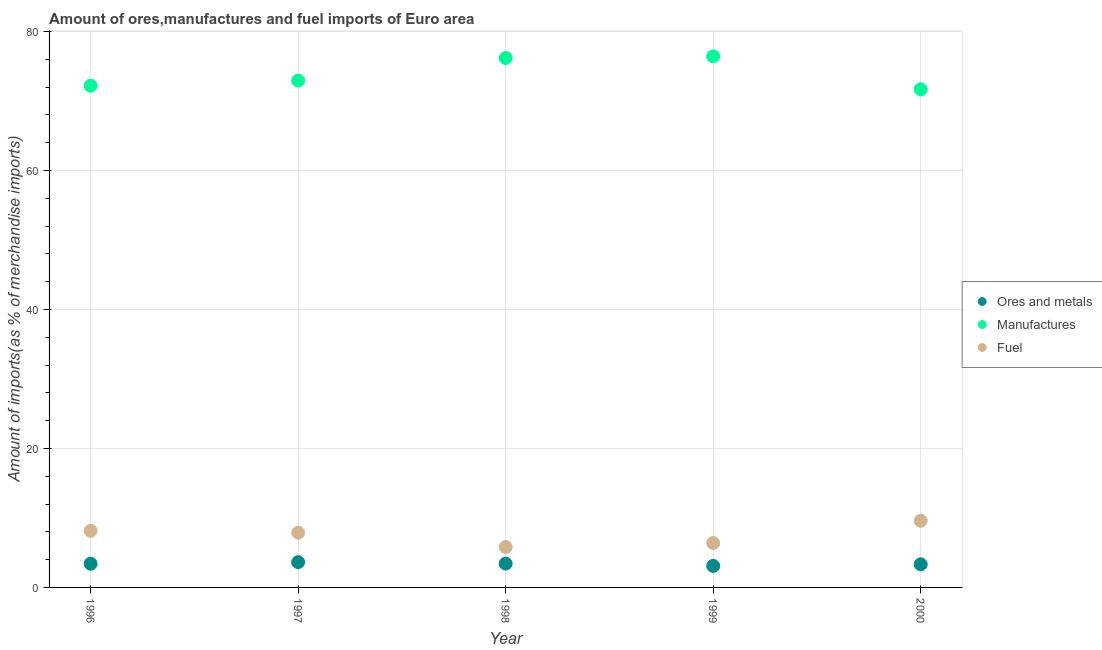How many different coloured dotlines are there?
Provide a short and direct response. 3. What is the percentage of manufactures imports in 1997?
Your response must be concise. 72.94. Across all years, what is the maximum percentage of fuel imports?
Offer a very short reply. 9.59. Across all years, what is the minimum percentage of fuel imports?
Offer a terse response. 5.81. In which year was the percentage of ores and metals imports minimum?
Provide a short and direct response. 1999. What is the total percentage of ores and metals imports in the graph?
Offer a terse response. 16.9. What is the difference between the percentage of ores and metals imports in 1996 and that in 1999?
Your answer should be compact. 0.31. What is the difference between the percentage of ores and metals imports in 1997 and the percentage of fuel imports in 2000?
Provide a succinct answer. -5.95. What is the average percentage of ores and metals imports per year?
Offer a very short reply. 3.38. In the year 1997, what is the difference between the percentage of fuel imports and percentage of ores and metals imports?
Offer a terse response. 4.24. In how many years, is the percentage of fuel imports greater than 40 %?
Provide a succinct answer. 0. What is the ratio of the percentage of ores and metals imports in 1996 to that in 1999?
Provide a succinct answer. 1.1. Is the percentage of ores and metals imports in 1997 less than that in 2000?
Offer a terse response. No. Is the difference between the percentage of ores and metals imports in 1996 and 2000 greater than the difference between the percentage of fuel imports in 1996 and 2000?
Ensure brevity in your answer.  Yes. What is the difference between the highest and the second highest percentage of ores and metals imports?
Provide a succinct answer. 0.21. What is the difference between the highest and the lowest percentage of manufactures imports?
Offer a terse response. 4.74. Is the sum of the percentage of manufactures imports in 1999 and 2000 greater than the maximum percentage of fuel imports across all years?
Your answer should be compact. Yes. Is it the case that in every year, the sum of the percentage of ores and metals imports and percentage of manufactures imports is greater than the percentage of fuel imports?
Ensure brevity in your answer.  Yes. Is the percentage of fuel imports strictly greater than the percentage of ores and metals imports over the years?
Provide a succinct answer. Yes. How many dotlines are there?
Offer a terse response. 3. How many years are there in the graph?
Your answer should be compact. 5. Does the graph contain any zero values?
Ensure brevity in your answer.  No. How many legend labels are there?
Ensure brevity in your answer.  3. How are the legend labels stacked?
Offer a very short reply. Vertical. What is the title of the graph?
Make the answer very short. Amount of ores,manufactures and fuel imports of Euro area. What is the label or title of the Y-axis?
Provide a short and direct response. Amount of imports(as % of merchandise imports). What is the Amount of imports(as % of merchandise imports) in Ores and metals in 1996?
Give a very brief answer. 3.41. What is the Amount of imports(as % of merchandise imports) of Manufactures in 1996?
Keep it short and to the point. 72.2. What is the Amount of imports(as % of merchandise imports) in Fuel in 1996?
Offer a terse response. 8.15. What is the Amount of imports(as % of merchandise imports) of Ores and metals in 1997?
Your answer should be compact. 3.64. What is the Amount of imports(as % of merchandise imports) of Manufactures in 1997?
Provide a short and direct response. 72.94. What is the Amount of imports(as % of merchandise imports) of Fuel in 1997?
Your answer should be compact. 7.88. What is the Amount of imports(as % of merchandise imports) of Ores and metals in 1998?
Your answer should be very brief. 3.43. What is the Amount of imports(as % of merchandise imports) in Manufactures in 1998?
Offer a very short reply. 76.19. What is the Amount of imports(as % of merchandise imports) of Fuel in 1998?
Provide a succinct answer. 5.81. What is the Amount of imports(as % of merchandise imports) of Ores and metals in 1999?
Keep it short and to the point. 3.1. What is the Amount of imports(as % of merchandise imports) in Manufactures in 1999?
Keep it short and to the point. 76.43. What is the Amount of imports(as % of merchandise imports) of Fuel in 1999?
Offer a very short reply. 6.39. What is the Amount of imports(as % of merchandise imports) in Ores and metals in 2000?
Make the answer very short. 3.33. What is the Amount of imports(as % of merchandise imports) of Manufactures in 2000?
Provide a succinct answer. 71.69. What is the Amount of imports(as % of merchandise imports) in Fuel in 2000?
Keep it short and to the point. 9.59. Across all years, what is the maximum Amount of imports(as % of merchandise imports) of Ores and metals?
Offer a terse response. 3.64. Across all years, what is the maximum Amount of imports(as % of merchandise imports) of Manufactures?
Your answer should be compact. 76.43. Across all years, what is the maximum Amount of imports(as % of merchandise imports) of Fuel?
Provide a succinct answer. 9.59. Across all years, what is the minimum Amount of imports(as % of merchandise imports) in Ores and metals?
Ensure brevity in your answer.  3.1. Across all years, what is the minimum Amount of imports(as % of merchandise imports) of Manufactures?
Make the answer very short. 71.69. Across all years, what is the minimum Amount of imports(as % of merchandise imports) in Fuel?
Offer a very short reply. 5.81. What is the total Amount of imports(as % of merchandise imports) of Ores and metals in the graph?
Provide a succinct answer. 16.9. What is the total Amount of imports(as % of merchandise imports) of Manufactures in the graph?
Give a very brief answer. 369.44. What is the total Amount of imports(as % of merchandise imports) of Fuel in the graph?
Provide a short and direct response. 37.82. What is the difference between the Amount of imports(as % of merchandise imports) of Ores and metals in 1996 and that in 1997?
Provide a succinct answer. -0.23. What is the difference between the Amount of imports(as % of merchandise imports) of Manufactures in 1996 and that in 1997?
Offer a terse response. -0.73. What is the difference between the Amount of imports(as % of merchandise imports) in Fuel in 1996 and that in 1997?
Your answer should be very brief. 0.27. What is the difference between the Amount of imports(as % of merchandise imports) in Ores and metals in 1996 and that in 1998?
Offer a very short reply. -0.02. What is the difference between the Amount of imports(as % of merchandise imports) in Manufactures in 1996 and that in 1998?
Make the answer very short. -3.98. What is the difference between the Amount of imports(as % of merchandise imports) of Fuel in 1996 and that in 1998?
Make the answer very short. 2.34. What is the difference between the Amount of imports(as % of merchandise imports) in Ores and metals in 1996 and that in 1999?
Provide a short and direct response. 0.31. What is the difference between the Amount of imports(as % of merchandise imports) in Manufactures in 1996 and that in 1999?
Provide a short and direct response. -4.23. What is the difference between the Amount of imports(as % of merchandise imports) of Fuel in 1996 and that in 1999?
Offer a terse response. 1.76. What is the difference between the Amount of imports(as % of merchandise imports) of Ores and metals in 1996 and that in 2000?
Your response must be concise. 0.08. What is the difference between the Amount of imports(as % of merchandise imports) in Manufactures in 1996 and that in 2000?
Make the answer very short. 0.51. What is the difference between the Amount of imports(as % of merchandise imports) in Fuel in 1996 and that in 2000?
Provide a short and direct response. -1.44. What is the difference between the Amount of imports(as % of merchandise imports) in Ores and metals in 1997 and that in 1998?
Ensure brevity in your answer.  0.21. What is the difference between the Amount of imports(as % of merchandise imports) of Manufactures in 1997 and that in 1998?
Ensure brevity in your answer.  -3.25. What is the difference between the Amount of imports(as % of merchandise imports) in Fuel in 1997 and that in 1998?
Provide a succinct answer. 2.06. What is the difference between the Amount of imports(as % of merchandise imports) in Ores and metals in 1997 and that in 1999?
Provide a succinct answer. 0.54. What is the difference between the Amount of imports(as % of merchandise imports) of Manufactures in 1997 and that in 1999?
Your answer should be compact. -3.49. What is the difference between the Amount of imports(as % of merchandise imports) in Fuel in 1997 and that in 1999?
Your response must be concise. 1.49. What is the difference between the Amount of imports(as % of merchandise imports) of Ores and metals in 1997 and that in 2000?
Make the answer very short. 0.31. What is the difference between the Amount of imports(as % of merchandise imports) of Manufactures in 1997 and that in 2000?
Keep it short and to the point. 1.25. What is the difference between the Amount of imports(as % of merchandise imports) of Fuel in 1997 and that in 2000?
Your answer should be compact. -1.71. What is the difference between the Amount of imports(as % of merchandise imports) of Ores and metals in 1998 and that in 1999?
Offer a very short reply. 0.33. What is the difference between the Amount of imports(as % of merchandise imports) of Manufactures in 1998 and that in 1999?
Your answer should be very brief. -0.25. What is the difference between the Amount of imports(as % of merchandise imports) of Fuel in 1998 and that in 1999?
Make the answer very short. -0.58. What is the difference between the Amount of imports(as % of merchandise imports) of Ores and metals in 1998 and that in 2000?
Keep it short and to the point. 0.1. What is the difference between the Amount of imports(as % of merchandise imports) in Manufactures in 1998 and that in 2000?
Your response must be concise. 4.5. What is the difference between the Amount of imports(as % of merchandise imports) of Fuel in 1998 and that in 2000?
Offer a very short reply. -3.78. What is the difference between the Amount of imports(as % of merchandise imports) in Ores and metals in 1999 and that in 2000?
Your answer should be compact. -0.23. What is the difference between the Amount of imports(as % of merchandise imports) of Manufactures in 1999 and that in 2000?
Keep it short and to the point. 4.74. What is the difference between the Amount of imports(as % of merchandise imports) in Fuel in 1999 and that in 2000?
Your answer should be compact. -3.2. What is the difference between the Amount of imports(as % of merchandise imports) in Ores and metals in 1996 and the Amount of imports(as % of merchandise imports) in Manufactures in 1997?
Make the answer very short. -69.53. What is the difference between the Amount of imports(as % of merchandise imports) in Ores and metals in 1996 and the Amount of imports(as % of merchandise imports) in Fuel in 1997?
Make the answer very short. -4.47. What is the difference between the Amount of imports(as % of merchandise imports) in Manufactures in 1996 and the Amount of imports(as % of merchandise imports) in Fuel in 1997?
Offer a very short reply. 64.32. What is the difference between the Amount of imports(as % of merchandise imports) in Ores and metals in 1996 and the Amount of imports(as % of merchandise imports) in Manufactures in 1998?
Keep it short and to the point. -72.78. What is the difference between the Amount of imports(as % of merchandise imports) of Ores and metals in 1996 and the Amount of imports(as % of merchandise imports) of Fuel in 1998?
Your answer should be compact. -2.41. What is the difference between the Amount of imports(as % of merchandise imports) of Manufactures in 1996 and the Amount of imports(as % of merchandise imports) of Fuel in 1998?
Provide a short and direct response. 66.39. What is the difference between the Amount of imports(as % of merchandise imports) in Ores and metals in 1996 and the Amount of imports(as % of merchandise imports) in Manufactures in 1999?
Your answer should be very brief. -73.02. What is the difference between the Amount of imports(as % of merchandise imports) in Ores and metals in 1996 and the Amount of imports(as % of merchandise imports) in Fuel in 1999?
Ensure brevity in your answer.  -2.98. What is the difference between the Amount of imports(as % of merchandise imports) of Manufactures in 1996 and the Amount of imports(as % of merchandise imports) of Fuel in 1999?
Ensure brevity in your answer.  65.81. What is the difference between the Amount of imports(as % of merchandise imports) in Ores and metals in 1996 and the Amount of imports(as % of merchandise imports) in Manufactures in 2000?
Make the answer very short. -68.28. What is the difference between the Amount of imports(as % of merchandise imports) in Ores and metals in 1996 and the Amount of imports(as % of merchandise imports) in Fuel in 2000?
Your response must be concise. -6.18. What is the difference between the Amount of imports(as % of merchandise imports) in Manufactures in 1996 and the Amount of imports(as % of merchandise imports) in Fuel in 2000?
Your answer should be compact. 62.61. What is the difference between the Amount of imports(as % of merchandise imports) in Ores and metals in 1997 and the Amount of imports(as % of merchandise imports) in Manufactures in 1998?
Offer a terse response. -72.55. What is the difference between the Amount of imports(as % of merchandise imports) in Ores and metals in 1997 and the Amount of imports(as % of merchandise imports) in Fuel in 1998?
Keep it short and to the point. -2.18. What is the difference between the Amount of imports(as % of merchandise imports) of Manufactures in 1997 and the Amount of imports(as % of merchandise imports) of Fuel in 1998?
Offer a terse response. 67.12. What is the difference between the Amount of imports(as % of merchandise imports) in Ores and metals in 1997 and the Amount of imports(as % of merchandise imports) in Manufactures in 1999?
Your answer should be very brief. -72.79. What is the difference between the Amount of imports(as % of merchandise imports) in Ores and metals in 1997 and the Amount of imports(as % of merchandise imports) in Fuel in 1999?
Keep it short and to the point. -2.75. What is the difference between the Amount of imports(as % of merchandise imports) of Manufactures in 1997 and the Amount of imports(as % of merchandise imports) of Fuel in 1999?
Offer a very short reply. 66.55. What is the difference between the Amount of imports(as % of merchandise imports) in Ores and metals in 1997 and the Amount of imports(as % of merchandise imports) in Manufactures in 2000?
Make the answer very short. -68.05. What is the difference between the Amount of imports(as % of merchandise imports) in Ores and metals in 1997 and the Amount of imports(as % of merchandise imports) in Fuel in 2000?
Offer a very short reply. -5.95. What is the difference between the Amount of imports(as % of merchandise imports) of Manufactures in 1997 and the Amount of imports(as % of merchandise imports) of Fuel in 2000?
Offer a terse response. 63.35. What is the difference between the Amount of imports(as % of merchandise imports) in Ores and metals in 1998 and the Amount of imports(as % of merchandise imports) in Manufactures in 1999?
Ensure brevity in your answer.  -73. What is the difference between the Amount of imports(as % of merchandise imports) of Ores and metals in 1998 and the Amount of imports(as % of merchandise imports) of Fuel in 1999?
Give a very brief answer. -2.96. What is the difference between the Amount of imports(as % of merchandise imports) in Manufactures in 1998 and the Amount of imports(as % of merchandise imports) in Fuel in 1999?
Give a very brief answer. 69.79. What is the difference between the Amount of imports(as % of merchandise imports) of Ores and metals in 1998 and the Amount of imports(as % of merchandise imports) of Manufactures in 2000?
Your answer should be compact. -68.26. What is the difference between the Amount of imports(as % of merchandise imports) of Ores and metals in 1998 and the Amount of imports(as % of merchandise imports) of Fuel in 2000?
Your answer should be compact. -6.16. What is the difference between the Amount of imports(as % of merchandise imports) of Manufactures in 1998 and the Amount of imports(as % of merchandise imports) of Fuel in 2000?
Your answer should be compact. 66.59. What is the difference between the Amount of imports(as % of merchandise imports) of Ores and metals in 1999 and the Amount of imports(as % of merchandise imports) of Manufactures in 2000?
Keep it short and to the point. -68.59. What is the difference between the Amount of imports(as % of merchandise imports) of Ores and metals in 1999 and the Amount of imports(as % of merchandise imports) of Fuel in 2000?
Give a very brief answer. -6.49. What is the difference between the Amount of imports(as % of merchandise imports) in Manufactures in 1999 and the Amount of imports(as % of merchandise imports) in Fuel in 2000?
Your answer should be compact. 66.84. What is the average Amount of imports(as % of merchandise imports) in Ores and metals per year?
Offer a terse response. 3.38. What is the average Amount of imports(as % of merchandise imports) of Manufactures per year?
Offer a very short reply. 73.89. What is the average Amount of imports(as % of merchandise imports) in Fuel per year?
Ensure brevity in your answer.  7.56. In the year 1996, what is the difference between the Amount of imports(as % of merchandise imports) of Ores and metals and Amount of imports(as % of merchandise imports) of Manufactures?
Provide a short and direct response. -68.79. In the year 1996, what is the difference between the Amount of imports(as % of merchandise imports) of Ores and metals and Amount of imports(as % of merchandise imports) of Fuel?
Your response must be concise. -4.74. In the year 1996, what is the difference between the Amount of imports(as % of merchandise imports) of Manufactures and Amount of imports(as % of merchandise imports) of Fuel?
Your response must be concise. 64.05. In the year 1997, what is the difference between the Amount of imports(as % of merchandise imports) of Ores and metals and Amount of imports(as % of merchandise imports) of Manufactures?
Your response must be concise. -69.3. In the year 1997, what is the difference between the Amount of imports(as % of merchandise imports) in Ores and metals and Amount of imports(as % of merchandise imports) in Fuel?
Keep it short and to the point. -4.24. In the year 1997, what is the difference between the Amount of imports(as % of merchandise imports) of Manufactures and Amount of imports(as % of merchandise imports) of Fuel?
Keep it short and to the point. 65.06. In the year 1998, what is the difference between the Amount of imports(as % of merchandise imports) of Ores and metals and Amount of imports(as % of merchandise imports) of Manufactures?
Your answer should be very brief. -72.76. In the year 1998, what is the difference between the Amount of imports(as % of merchandise imports) of Ores and metals and Amount of imports(as % of merchandise imports) of Fuel?
Ensure brevity in your answer.  -2.39. In the year 1998, what is the difference between the Amount of imports(as % of merchandise imports) in Manufactures and Amount of imports(as % of merchandise imports) in Fuel?
Ensure brevity in your answer.  70.37. In the year 1999, what is the difference between the Amount of imports(as % of merchandise imports) in Ores and metals and Amount of imports(as % of merchandise imports) in Manufactures?
Ensure brevity in your answer.  -73.33. In the year 1999, what is the difference between the Amount of imports(as % of merchandise imports) in Ores and metals and Amount of imports(as % of merchandise imports) in Fuel?
Provide a succinct answer. -3.29. In the year 1999, what is the difference between the Amount of imports(as % of merchandise imports) of Manufactures and Amount of imports(as % of merchandise imports) of Fuel?
Ensure brevity in your answer.  70.04. In the year 2000, what is the difference between the Amount of imports(as % of merchandise imports) in Ores and metals and Amount of imports(as % of merchandise imports) in Manufactures?
Offer a very short reply. -68.36. In the year 2000, what is the difference between the Amount of imports(as % of merchandise imports) of Ores and metals and Amount of imports(as % of merchandise imports) of Fuel?
Make the answer very short. -6.26. In the year 2000, what is the difference between the Amount of imports(as % of merchandise imports) of Manufactures and Amount of imports(as % of merchandise imports) of Fuel?
Give a very brief answer. 62.1. What is the ratio of the Amount of imports(as % of merchandise imports) in Ores and metals in 1996 to that in 1997?
Offer a terse response. 0.94. What is the ratio of the Amount of imports(as % of merchandise imports) in Manufactures in 1996 to that in 1997?
Keep it short and to the point. 0.99. What is the ratio of the Amount of imports(as % of merchandise imports) in Fuel in 1996 to that in 1997?
Ensure brevity in your answer.  1.03. What is the ratio of the Amount of imports(as % of merchandise imports) of Manufactures in 1996 to that in 1998?
Give a very brief answer. 0.95. What is the ratio of the Amount of imports(as % of merchandise imports) of Fuel in 1996 to that in 1998?
Provide a succinct answer. 1.4. What is the ratio of the Amount of imports(as % of merchandise imports) of Ores and metals in 1996 to that in 1999?
Offer a very short reply. 1.1. What is the ratio of the Amount of imports(as % of merchandise imports) in Manufactures in 1996 to that in 1999?
Offer a very short reply. 0.94. What is the ratio of the Amount of imports(as % of merchandise imports) in Fuel in 1996 to that in 1999?
Offer a terse response. 1.27. What is the ratio of the Amount of imports(as % of merchandise imports) of Ores and metals in 1996 to that in 2000?
Give a very brief answer. 1.02. What is the ratio of the Amount of imports(as % of merchandise imports) of Fuel in 1996 to that in 2000?
Ensure brevity in your answer.  0.85. What is the ratio of the Amount of imports(as % of merchandise imports) of Ores and metals in 1997 to that in 1998?
Provide a short and direct response. 1.06. What is the ratio of the Amount of imports(as % of merchandise imports) in Manufactures in 1997 to that in 1998?
Provide a short and direct response. 0.96. What is the ratio of the Amount of imports(as % of merchandise imports) in Fuel in 1997 to that in 1998?
Offer a terse response. 1.35. What is the ratio of the Amount of imports(as % of merchandise imports) of Ores and metals in 1997 to that in 1999?
Give a very brief answer. 1.17. What is the ratio of the Amount of imports(as % of merchandise imports) in Manufactures in 1997 to that in 1999?
Your answer should be very brief. 0.95. What is the ratio of the Amount of imports(as % of merchandise imports) of Fuel in 1997 to that in 1999?
Give a very brief answer. 1.23. What is the ratio of the Amount of imports(as % of merchandise imports) in Ores and metals in 1997 to that in 2000?
Give a very brief answer. 1.09. What is the ratio of the Amount of imports(as % of merchandise imports) of Manufactures in 1997 to that in 2000?
Your answer should be compact. 1.02. What is the ratio of the Amount of imports(as % of merchandise imports) in Fuel in 1997 to that in 2000?
Give a very brief answer. 0.82. What is the ratio of the Amount of imports(as % of merchandise imports) in Ores and metals in 1998 to that in 1999?
Your answer should be compact. 1.11. What is the ratio of the Amount of imports(as % of merchandise imports) of Manufactures in 1998 to that in 1999?
Make the answer very short. 1. What is the ratio of the Amount of imports(as % of merchandise imports) in Fuel in 1998 to that in 1999?
Offer a very short reply. 0.91. What is the ratio of the Amount of imports(as % of merchandise imports) of Ores and metals in 1998 to that in 2000?
Make the answer very short. 1.03. What is the ratio of the Amount of imports(as % of merchandise imports) in Manufactures in 1998 to that in 2000?
Your response must be concise. 1.06. What is the ratio of the Amount of imports(as % of merchandise imports) of Fuel in 1998 to that in 2000?
Give a very brief answer. 0.61. What is the ratio of the Amount of imports(as % of merchandise imports) of Ores and metals in 1999 to that in 2000?
Your response must be concise. 0.93. What is the ratio of the Amount of imports(as % of merchandise imports) of Manufactures in 1999 to that in 2000?
Ensure brevity in your answer.  1.07. What is the ratio of the Amount of imports(as % of merchandise imports) of Fuel in 1999 to that in 2000?
Your answer should be very brief. 0.67. What is the difference between the highest and the second highest Amount of imports(as % of merchandise imports) of Ores and metals?
Offer a terse response. 0.21. What is the difference between the highest and the second highest Amount of imports(as % of merchandise imports) in Manufactures?
Provide a succinct answer. 0.25. What is the difference between the highest and the second highest Amount of imports(as % of merchandise imports) in Fuel?
Provide a short and direct response. 1.44. What is the difference between the highest and the lowest Amount of imports(as % of merchandise imports) of Ores and metals?
Ensure brevity in your answer.  0.54. What is the difference between the highest and the lowest Amount of imports(as % of merchandise imports) of Manufactures?
Ensure brevity in your answer.  4.74. What is the difference between the highest and the lowest Amount of imports(as % of merchandise imports) of Fuel?
Your answer should be very brief. 3.78. 